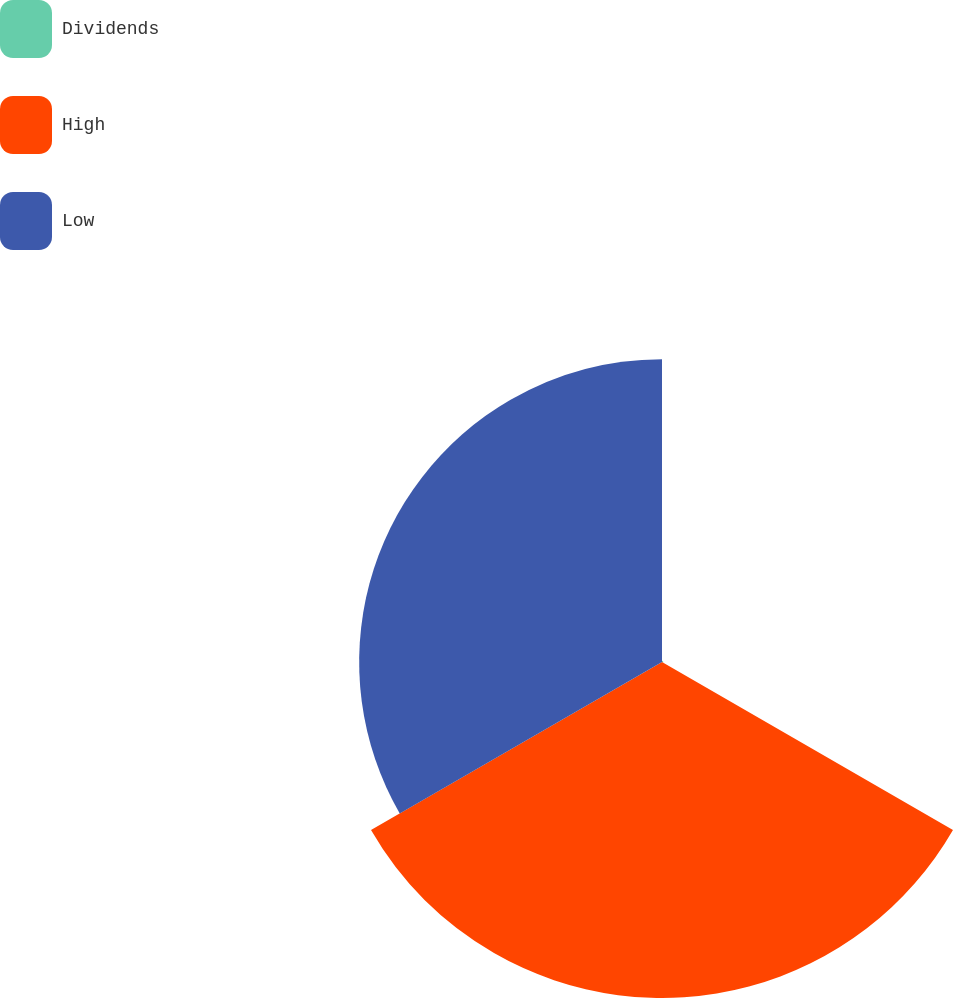Convert chart to OTSL. <chart><loc_0><loc_0><loc_500><loc_500><pie_chart><fcel>Dividends<fcel>High<fcel>Low<nl><fcel>0.2%<fcel>52.49%<fcel>47.31%<nl></chart> 